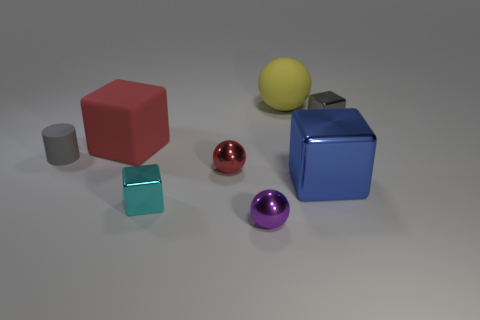Subtract all gray metal blocks. How many blocks are left? 3 Add 2 tiny gray objects. How many objects exist? 10 Subtract all red blocks. Subtract all blue balls. How many blocks are left? 3 Subtract all red cubes. How many cubes are left? 3 Subtract 0 blue balls. How many objects are left? 8 Subtract all spheres. How many objects are left? 5 Subtract 3 blocks. How many blocks are left? 1 Subtract all red cylinders. How many yellow balls are left? 1 Subtract all blue things. Subtract all purple spheres. How many objects are left? 6 Add 5 blue cubes. How many blue cubes are left? 6 